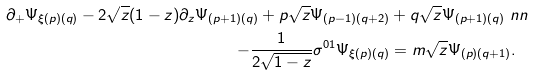<formula> <loc_0><loc_0><loc_500><loc_500>\partial _ { + } \Psi _ { \xi ( p ) ( q ) } - 2 \sqrt { z } ( 1 - z ) \partial _ { z } \Psi _ { ( p + 1 ) ( q ) } + p \sqrt { z } \Psi _ { ( p - 1 ) ( q + 2 ) } & + q \sqrt { z } \Psi _ { ( p + 1 ) ( q ) } \ n n \\ - \frac { 1 } { 2 \sqrt { 1 - z } } \sigma ^ { 0 1 } \Psi _ { \xi ( p ) ( q ) } & = m \sqrt { z } \Psi _ { ( p ) ( q + 1 ) } .</formula> 